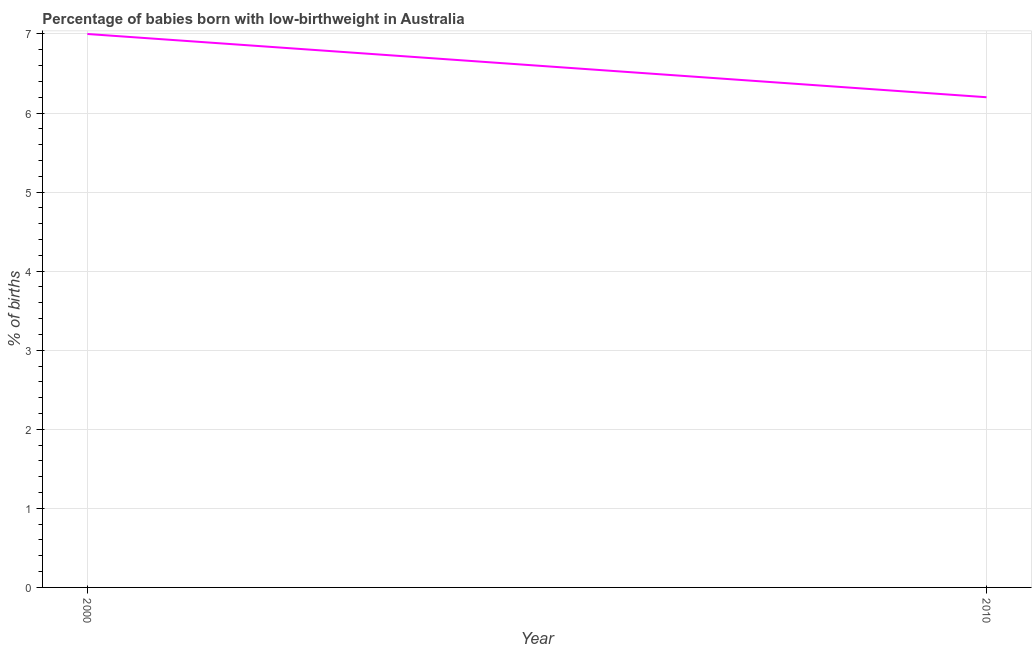Across all years, what is the minimum percentage of babies who were born with low-birthweight?
Offer a very short reply. 6.2. In which year was the percentage of babies who were born with low-birthweight maximum?
Make the answer very short. 2000. In which year was the percentage of babies who were born with low-birthweight minimum?
Your response must be concise. 2010. What is the sum of the percentage of babies who were born with low-birthweight?
Offer a very short reply. 13.2. What is the difference between the percentage of babies who were born with low-birthweight in 2000 and 2010?
Offer a terse response. 0.8. What is the average percentage of babies who were born with low-birthweight per year?
Provide a succinct answer. 6.6. Do a majority of the years between 2010 and 2000 (inclusive) have percentage of babies who were born with low-birthweight greater than 3.8 %?
Offer a terse response. No. What is the ratio of the percentage of babies who were born with low-birthweight in 2000 to that in 2010?
Your answer should be compact. 1.13. Is the percentage of babies who were born with low-birthweight in 2000 less than that in 2010?
Provide a short and direct response. No. In how many years, is the percentage of babies who were born with low-birthweight greater than the average percentage of babies who were born with low-birthweight taken over all years?
Your answer should be compact. 1. Does the percentage of babies who were born with low-birthweight monotonically increase over the years?
Offer a very short reply. No. What is the difference between two consecutive major ticks on the Y-axis?
Provide a succinct answer. 1. Does the graph contain any zero values?
Offer a terse response. No. Does the graph contain grids?
Provide a short and direct response. Yes. What is the title of the graph?
Provide a succinct answer. Percentage of babies born with low-birthweight in Australia. What is the label or title of the Y-axis?
Make the answer very short. % of births. What is the ratio of the % of births in 2000 to that in 2010?
Offer a very short reply. 1.13. 